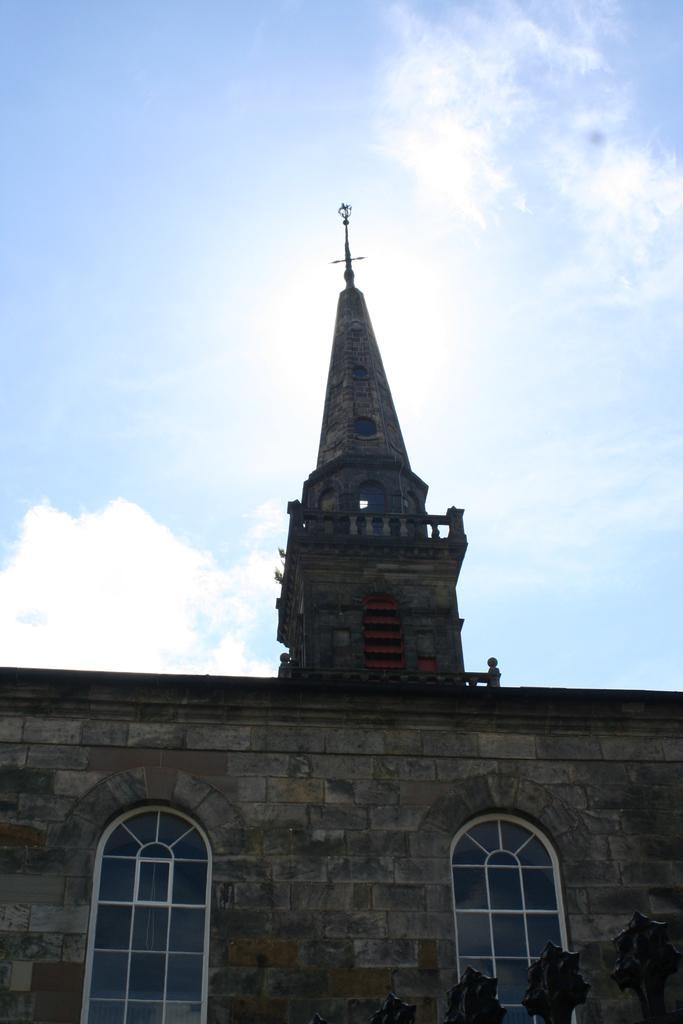Please provide a concise description of this image. In this image we can see a building and glass windows. In the background there is sky with clouds. 